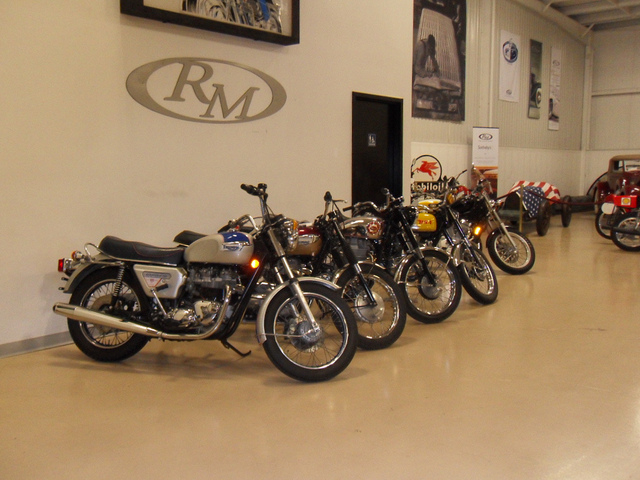Identify the text displayed in this image. RM 